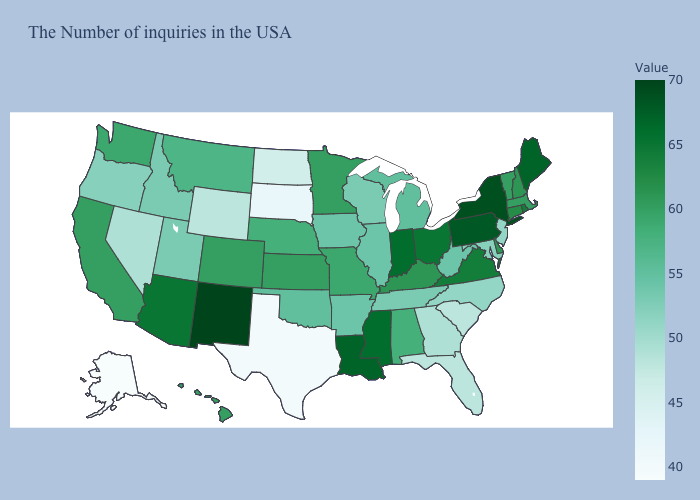Which states have the lowest value in the USA?
Be succinct. Alaska. Does New Mexico have the highest value in the USA?
Write a very short answer. Yes. Does Alabama have a lower value than New Mexico?
Give a very brief answer. Yes. Which states have the lowest value in the USA?
Answer briefly. Alaska. Among the states that border California , which have the highest value?
Short answer required. Arizona. Among the states that border Arizona , which have the lowest value?
Quick response, please. Nevada. 